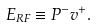<formula> <loc_0><loc_0><loc_500><loc_500>E _ { R F } \equiv P ^ { - } v ^ { + } .</formula> 